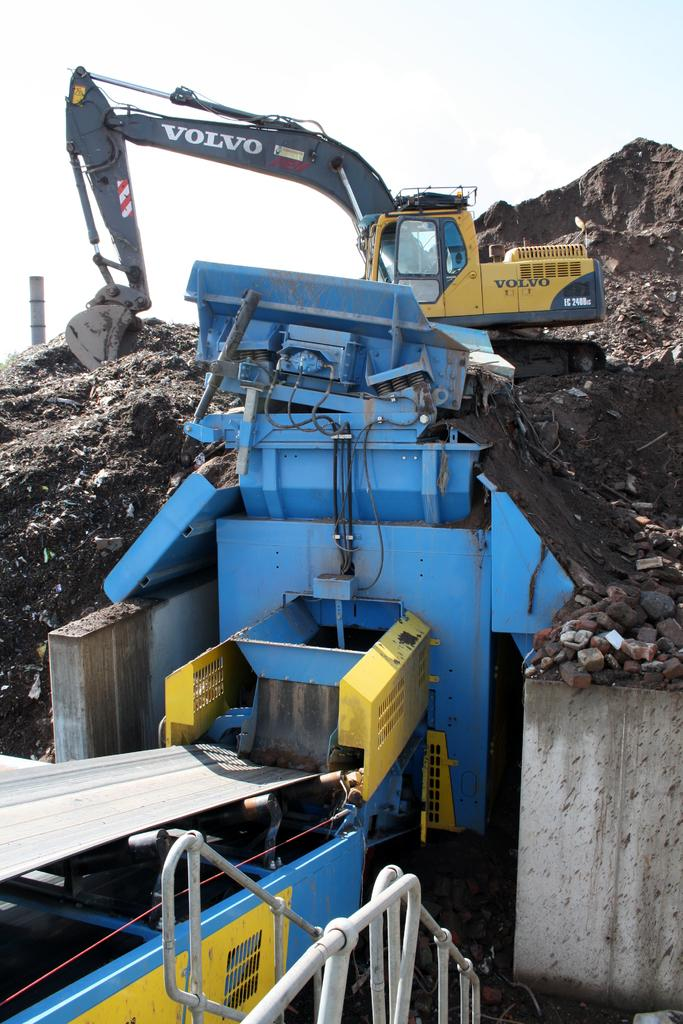What is the main subject of the image? The main subject of the image is a mud removing machine. What is the purpose of the machine and equipment in the image? The mud removing machine and equipment are removing mud. What can be seen in the background of the image? The sky is visible in the image. What type of milk is being poured into the mud removing machine in the image? There is no milk present in the image; it features a mud removing machine and equipment removing mud. Can you see any gardens in the image? There is no garden present in the image. 